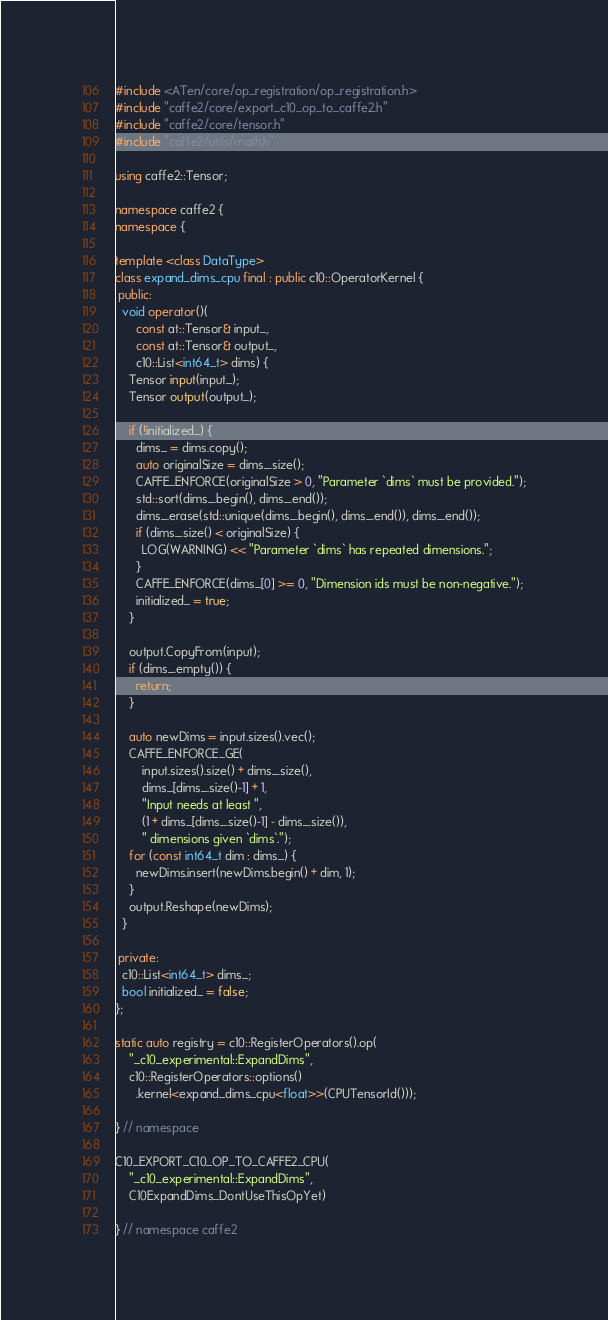<code> <loc_0><loc_0><loc_500><loc_500><_C++_>#include <ATen/core/op_registration/op_registration.h>
#include "caffe2/core/export_c10_op_to_caffe2.h"
#include "caffe2/core/tensor.h"
#include "caffe2/utils/math.h"

using caffe2::Tensor;

namespace caffe2 {
namespace {

template <class DataType>
class expand_dims_cpu final : public c10::OperatorKernel {
 public:
  void operator()(
      const at::Tensor& input_,
      const at::Tensor& output_,
      c10::List<int64_t> dims) {
    Tensor input(input_);
    Tensor output(output_);

    if (!initialized_) {
      dims_ = dims.copy();
      auto originalSize = dims_.size();
      CAFFE_ENFORCE(originalSize > 0, "Parameter `dims` must be provided.");
      std::sort(dims_.begin(), dims_.end());
      dims_.erase(std::unique(dims_.begin(), dims_.end()), dims_.end());
      if (dims_.size() < originalSize) {
        LOG(WARNING) << "Parameter `dims` has repeated dimensions.";
      }
      CAFFE_ENFORCE(dims_[0] >= 0, "Dimension ids must be non-negative.");
      initialized_ = true;
    }

    output.CopyFrom(input);
    if (dims_.empty()) {
      return;
    }

    auto newDims = input.sizes().vec();
    CAFFE_ENFORCE_GE(
        input.sizes().size() + dims_.size(),
        dims_[dims_.size()-1] + 1,
        "Input needs at least ",
        (1 + dims_[dims_.size()-1] - dims_.size()),
        " dimensions given `dims`.");
    for (const int64_t dim : dims_) {
      newDims.insert(newDims.begin() + dim, 1);
    }
    output.Reshape(newDims);
  }

 private:
  c10::List<int64_t> dims_;
  bool initialized_ = false;
};

static auto registry = c10::RegisterOperators().op(
    "_c10_experimental::ExpandDims",
    c10::RegisterOperators::options()
      .kernel<expand_dims_cpu<float>>(CPUTensorId()));

} // namespace

C10_EXPORT_C10_OP_TO_CAFFE2_CPU(
    "_c10_experimental::ExpandDims",
    C10ExpandDims_DontUseThisOpYet)

} // namespace caffe2
</code> 